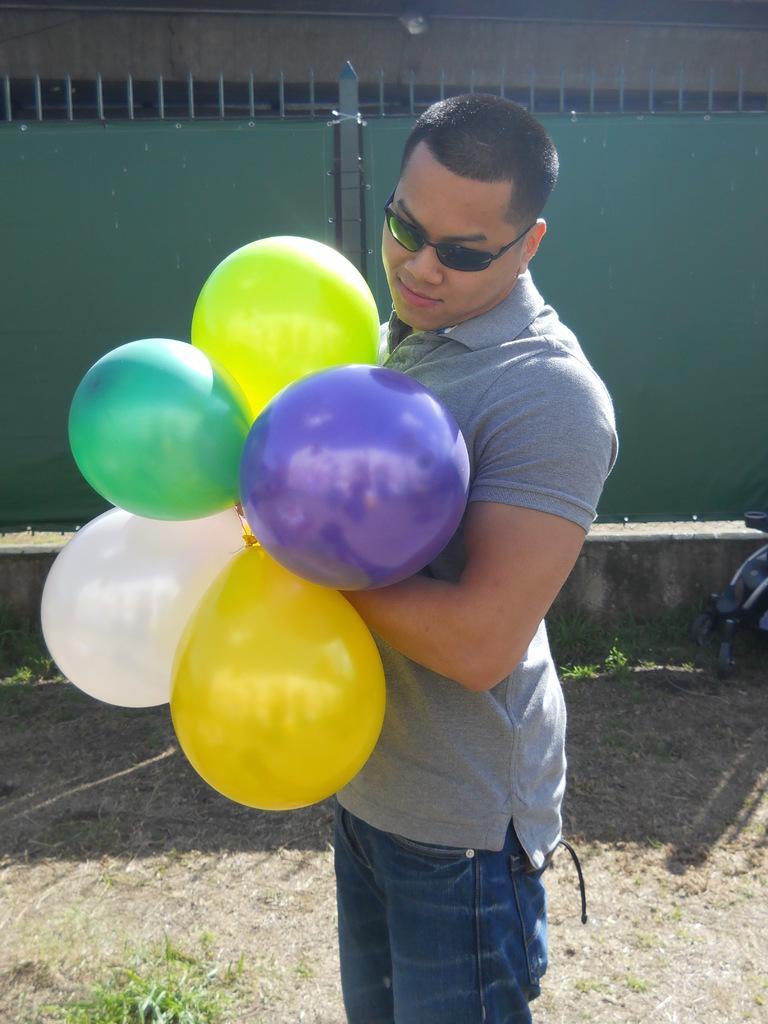Can you describe this image briefly? In the image I can see a person who is wearing the spectacles and holding the balloons. 